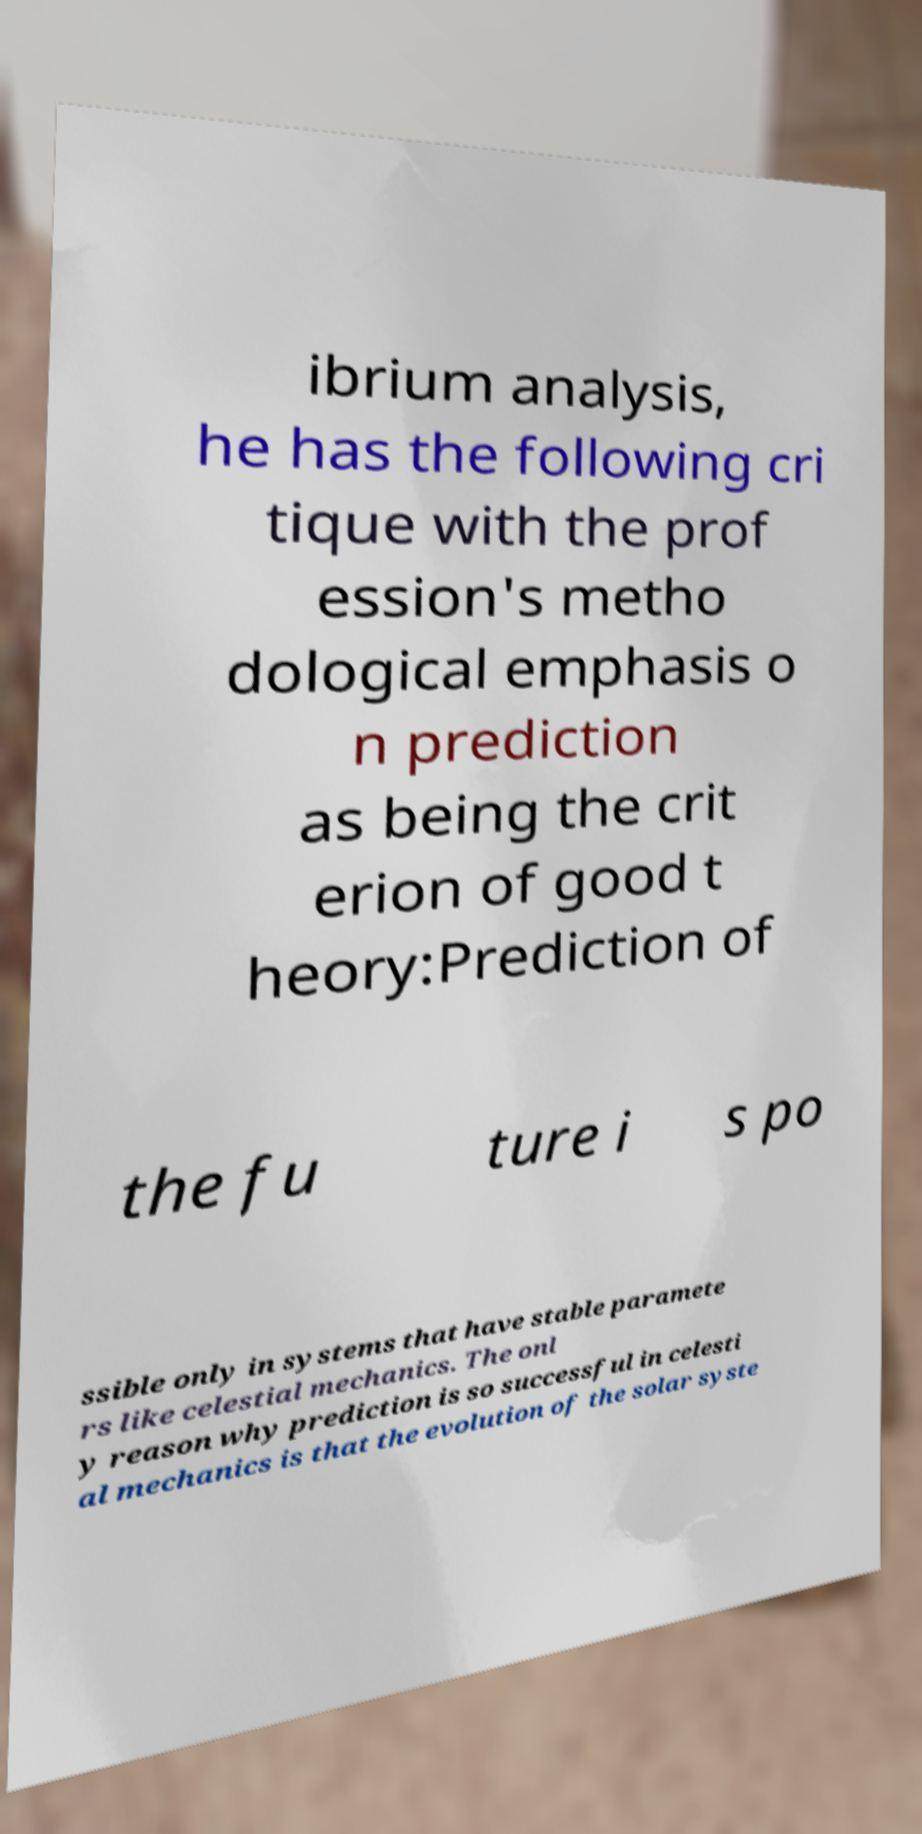Can you read and provide the text displayed in the image?This photo seems to have some interesting text. Can you extract and type it out for me? ibrium analysis, he has the following cri tique with the prof ession's metho dological emphasis o n prediction as being the crit erion of good t heory:Prediction of the fu ture i s po ssible only in systems that have stable paramete rs like celestial mechanics. The onl y reason why prediction is so successful in celesti al mechanics is that the evolution of the solar syste 